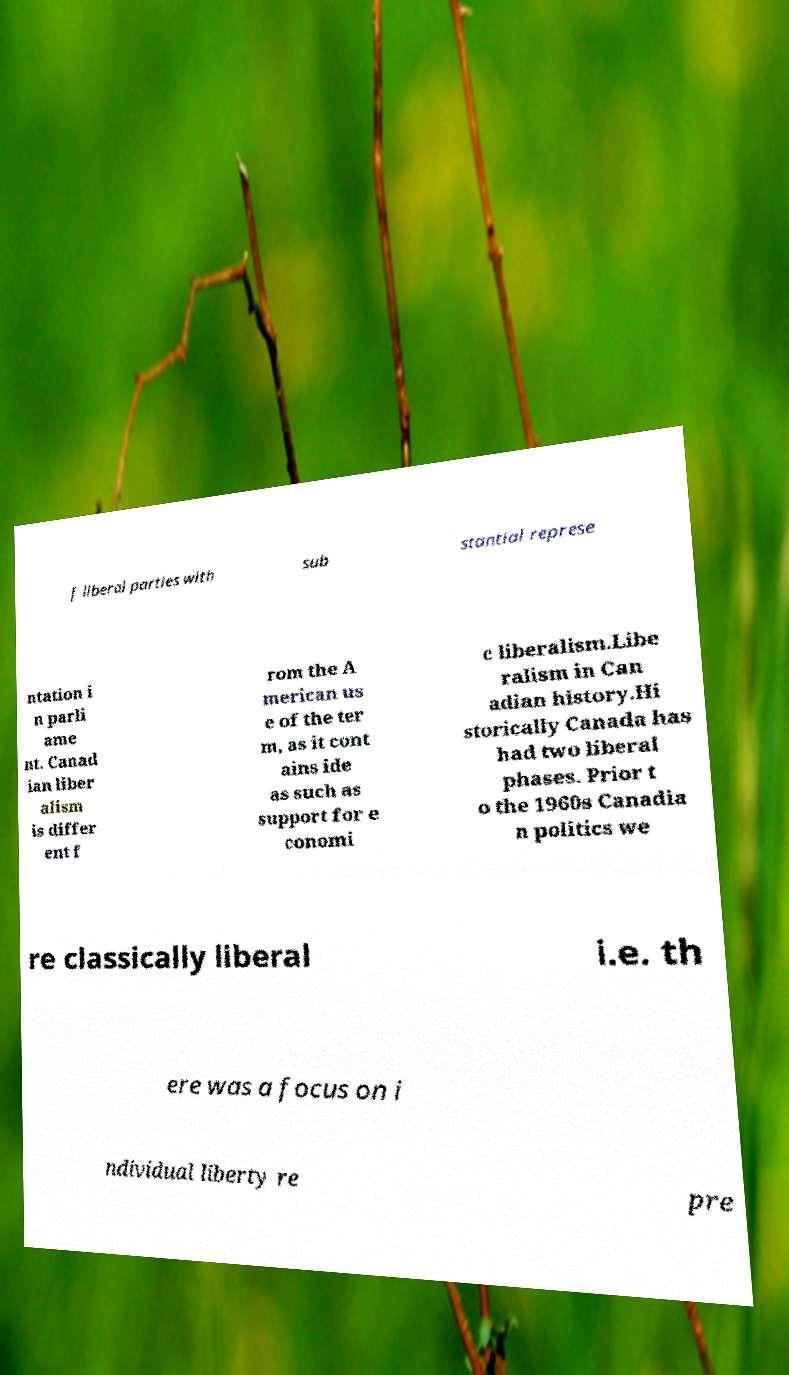What messages or text are displayed in this image? I need them in a readable, typed format. f liberal parties with sub stantial represe ntation i n parli ame nt. Canad ian liber alism is differ ent f rom the A merican us e of the ter m, as it cont ains ide as such as support for e conomi c liberalism.Libe ralism in Can adian history.Hi storically Canada has had two liberal phases. Prior t o the 1960s Canadia n politics we re classically liberal i.e. th ere was a focus on i ndividual liberty re pre 